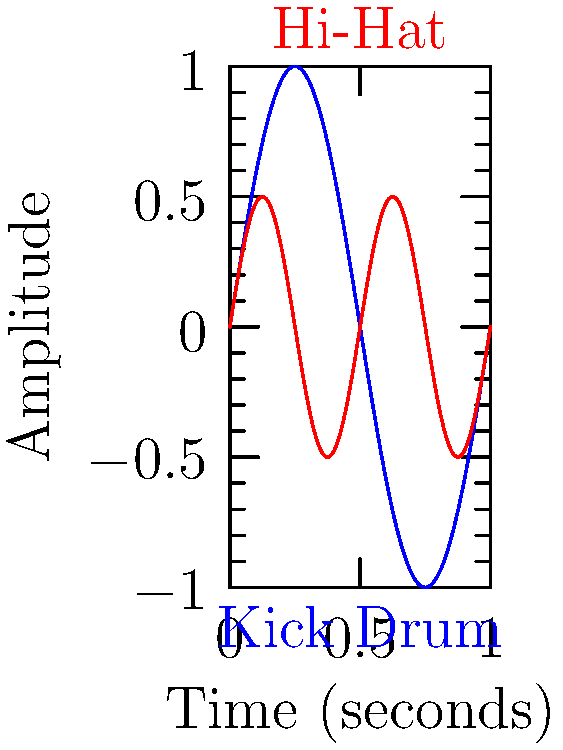In a hip-hop drum loop, the kick drum and hi-hat patterns can be modeled using sinusoidal functions. The kick drum follows the function $f(x) = \sin(2\pi x)$, while the hi-hat follows $g(x) = 0.5\sin(4\pi x)$, where $x$ represents time in seconds. At what time within the first second do these two instruments hit simultaneously at their peak amplitudes? To solve this, we need to follow these steps:

1) For the instruments to hit simultaneously at peak amplitudes, we need to find where both functions equal their maximum values at the same time.

2) For $f(x) = \sin(2\pi x)$:
   Maximum value is 1, which occurs when $2\pi x = \frac{\pi}{2} + 2\pi n$, where n is an integer.
   Solving for x: $x = \frac{1}{4} + \frac{n}{2}$

3) For $g(x) = 0.5\sin(4\pi x)$:
   Maximum value is 0.5, which occurs when $4\pi x = \frac{\pi}{2} + 2\pi n$
   Solving for x: $x = \frac{1}{8} + \frac{n}{4}$

4) We need to find a value of x that satisfies both conditions within the first second (0 ≤ x < 1).

5) The first simultaneous peak occurs at $x = \frac{1}{4}$, which satisfies both equations when n = 0 for $f(x)$ and n = 1 for $g(x)$.

Therefore, the kick drum and hi-hat hit simultaneously at their peak amplitudes at 0.25 seconds.
Answer: 0.25 seconds 